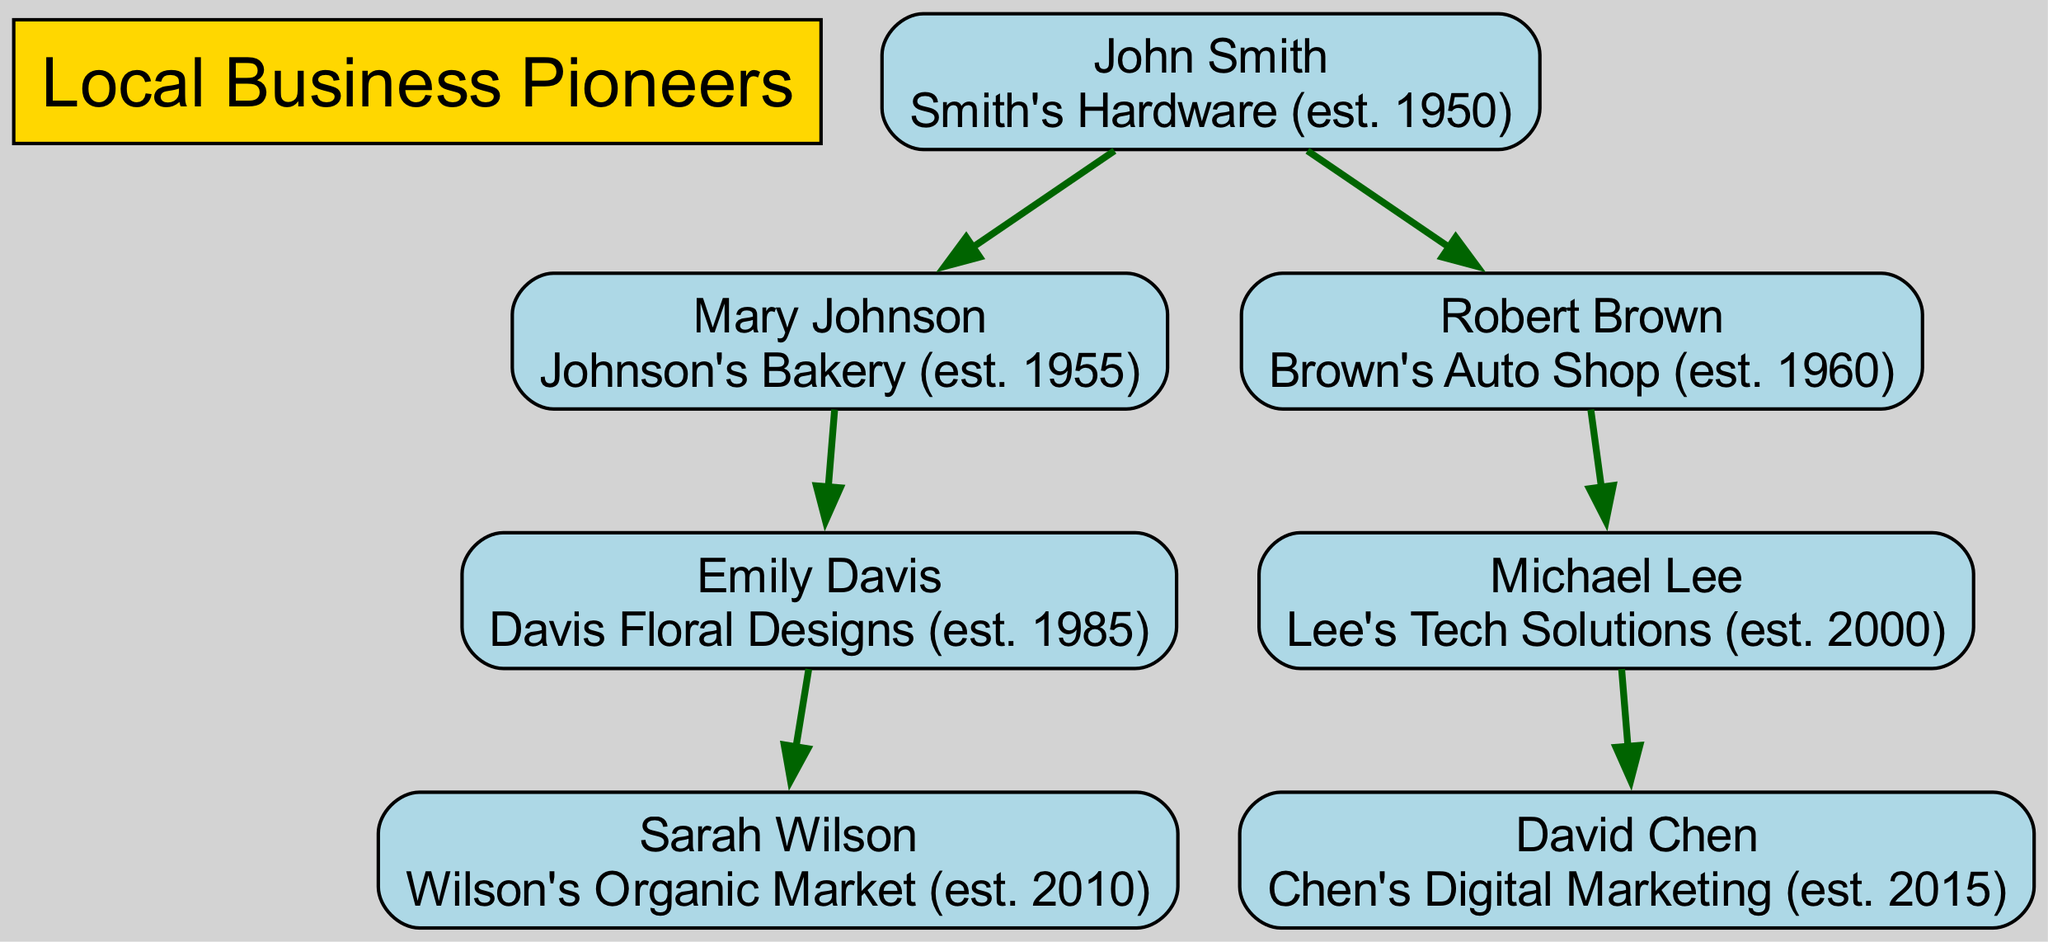What is the business established by John Smith? The diagram shows John Smith's name along with his business listed below it. The text indicates his business as "Smith's Hardware (est. 1950)."
Answer: Smith's Hardware (est. 1950) How many generations of entrepreneurs are represented in the diagram? By examining the diagram, the generations can be counted from the root down to the leaves. There are three generations: John Smith, his children Mary Johnson and Robert Brown, and their descendants.
Answer: 3 Who is the parent of Emily Davis? Looking at the diagram, Emily Davis is directly connected to her parent, Mary Johnson. The relationship is defined with an edge originating from Mary Johnson pointing to Emily Davis.
Answer: Mary Johnson Which business was established first among the listed ventures? By evaluating the establishment years mentioned alongside the businesses in the diagram, Smith's Hardware is noted as established in 1950, which is the earliest year compared to the others.
Answer: Smith's Hardware What is the most recent business established in the tree? The diagram lists the establishment years of all businesses. Chen's Digital Marketing is mentioned to have been established in 2015, making it the most recent venture.
Answer: Chen's Digital Marketing Which entrepreneur has the most businesses listed under them? Analyzing the diagram, John Smith has two children who are both entrepreneurs, thus he can be seen as having the most business entities descending from him. However, each child operates one business.
Answer: John Smith Which business does Michael Lee operate? Michael Lee's node in the diagram includes his name and directly below it, the business name "Lee's Tech Solutions (est. 2000)" is displayed, providing the requested information.
Answer: Lee's Tech Solutions (est. 2000) Who is the parent of David Chen? The diagram shows a direct relationship with an edge leading from Michael Lee to David Chen, establishing that Michael Lee is the parent of David.
Answer: Michael Lee What are the establishment years of Sarah Wilson's business? Inspecting the node for Sarah Wilson in the diagram, her business is noted as "Wilson's Organic Market (est. 2010)," revealing the year of establishment directly.
Answer: 2010 